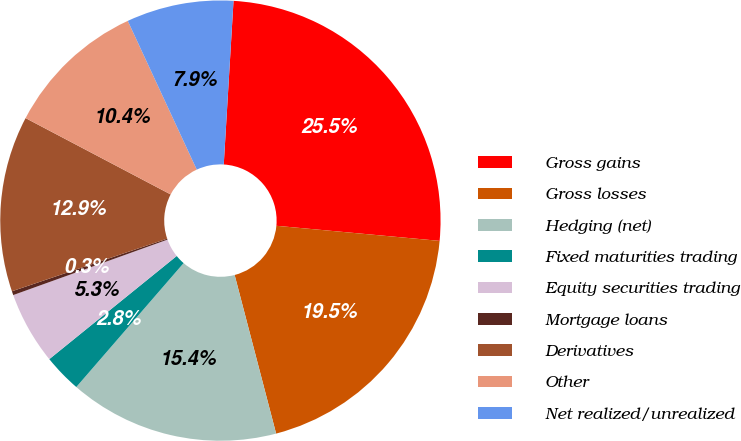<chart> <loc_0><loc_0><loc_500><loc_500><pie_chart><fcel>Gross gains<fcel>Gross losses<fcel>Hedging (net)<fcel>Fixed maturities trading<fcel>Equity securities trading<fcel>Mortgage loans<fcel>Derivatives<fcel>Other<fcel>Net realized/unrealized<nl><fcel>25.52%<fcel>19.46%<fcel>15.43%<fcel>2.81%<fcel>5.34%<fcel>0.29%<fcel>12.91%<fcel>10.38%<fcel>7.86%<nl></chart> 